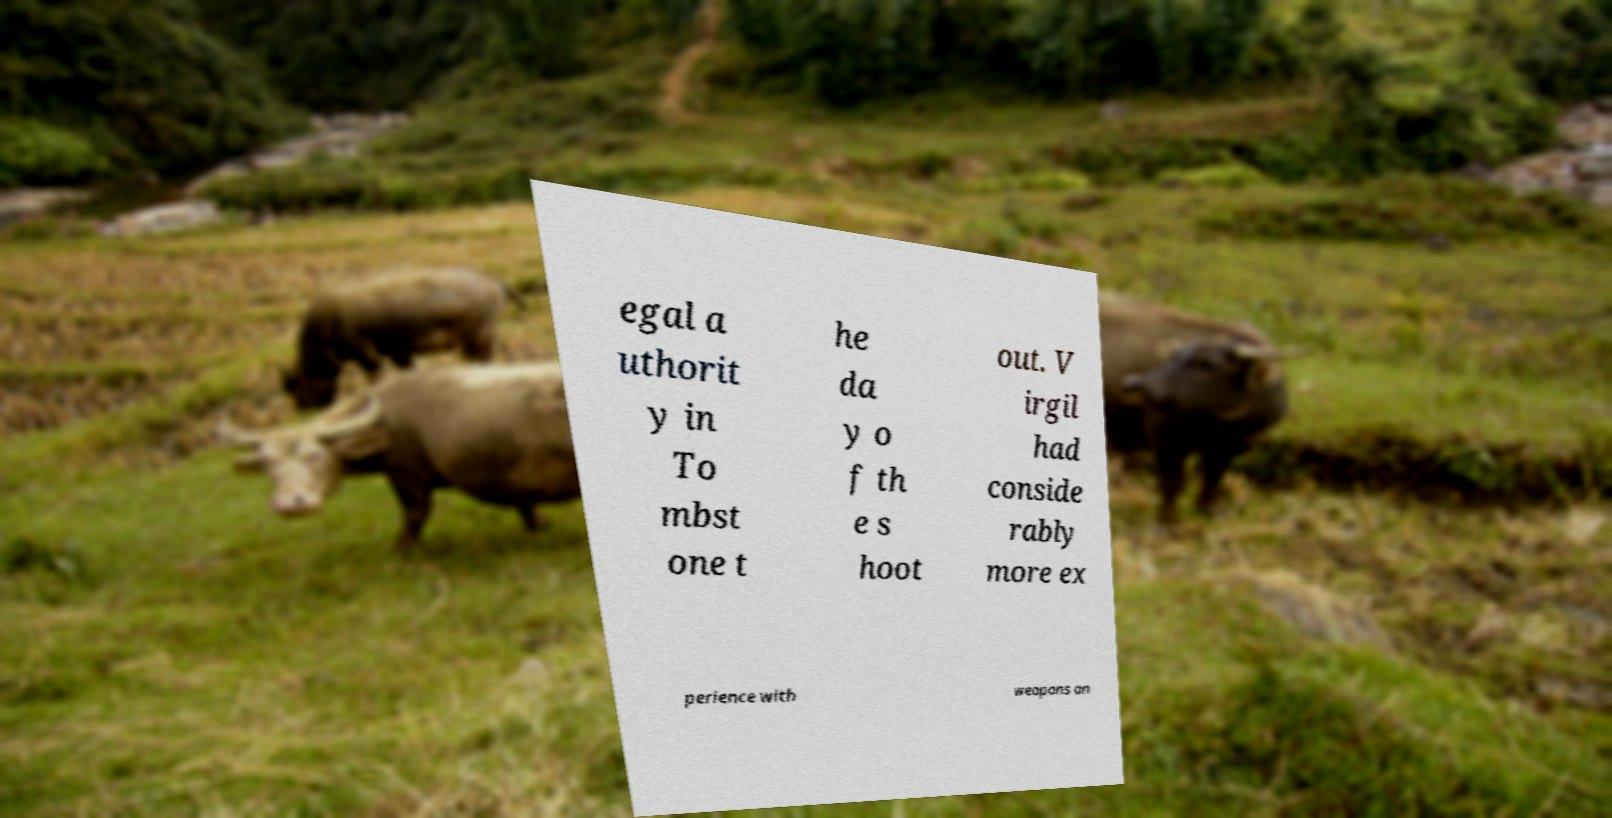There's text embedded in this image that I need extracted. Can you transcribe it verbatim? egal a uthorit y in To mbst one t he da y o f th e s hoot out. V irgil had conside rably more ex perience with weapons an 